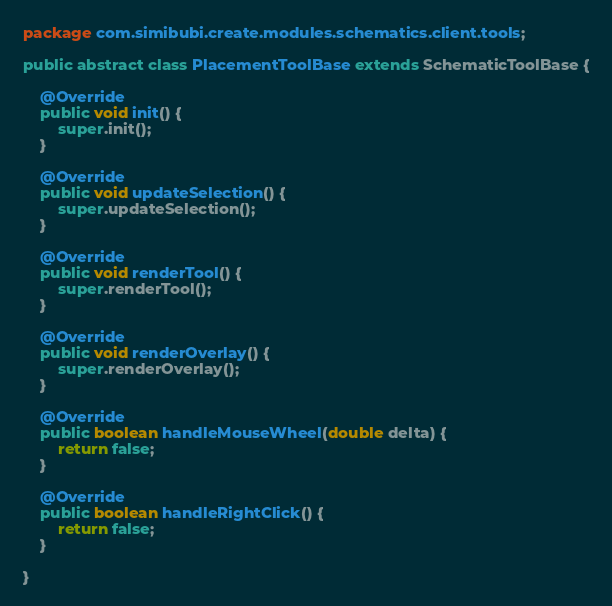<code> <loc_0><loc_0><loc_500><loc_500><_Java_>package com.simibubi.create.modules.schematics.client.tools;

public abstract class PlacementToolBase extends SchematicToolBase {

	@Override
	public void init() {
		super.init();
	}
	
	@Override
	public void updateSelection() {
		super.updateSelection();
	}
	
	@Override
	public void renderTool() {
		super.renderTool();
	}

	@Override
	public void renderOverlay() {
		super.renderOverlay();
	}
	
	@Override
	public boolean handleMouseWheel(double delta) {
		return false;
	}
	
	@Override
	public boolean handleRightClick() {
		return false;
	}
	
}
</code> 